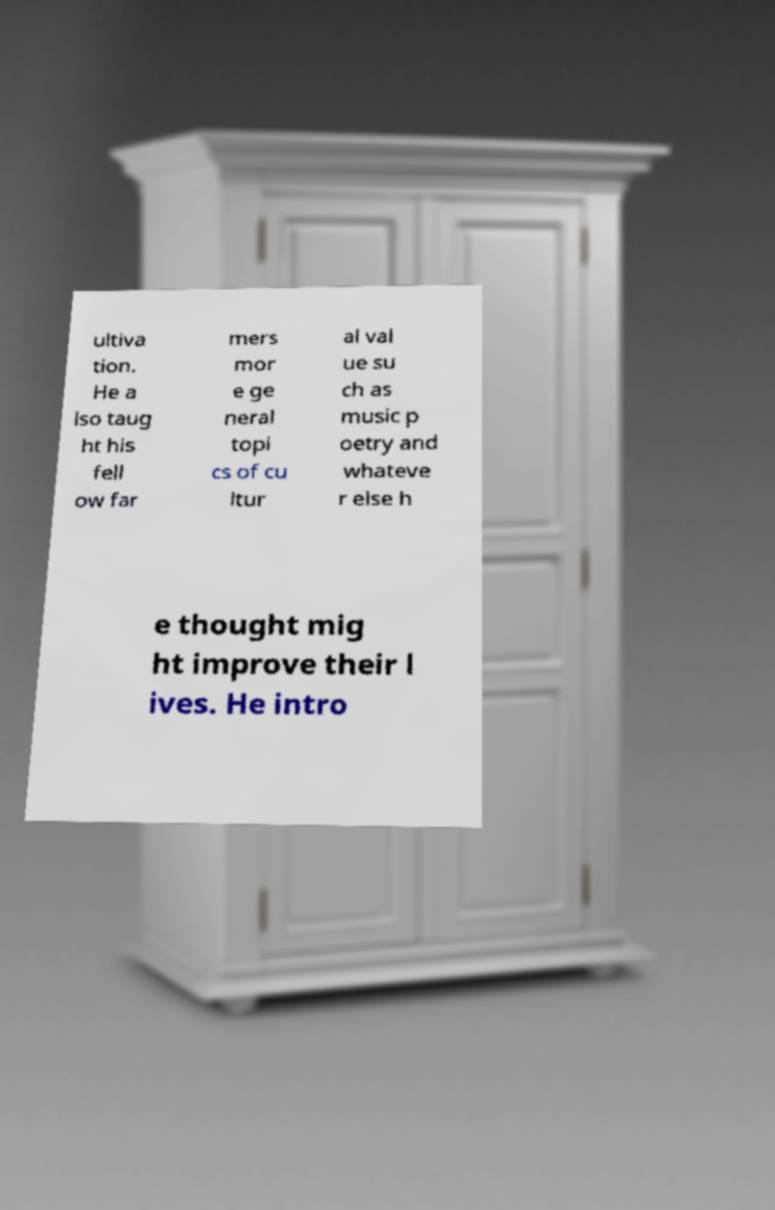Could you assist in decoding the text presented in this image and type it out clearly? ultiva tion. He a lso taug ht his fell ow far mers mor e ge neral topi cs of cu ltur al val ue su ch as music p oetry and whateve r else h e thought mig ht improve their l ives. He intro 